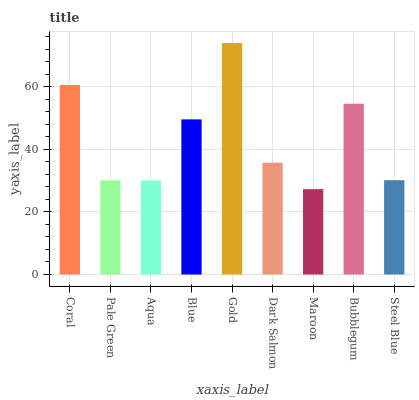Is Maroon the minimum?
Answer yes or no. Yes. Is Gold the maximum?
Answer yes or no. Yes. Is Pale Green the minimum?
Answer yes or no. No. Is Pale Green the maximum?
Answer yes or no. No. Is Coral greater than Pale Green?
Answer yes or no. Yes. Is Pale Green less than Coral?
Answer yes or no. Yes. Is Pale Green greater than Coral?
Answer yes or no. No. Is Coral less than Pale Green?
Answer yes or no. No. Is Dark Salmon the high median?
Answer yes or no. Yes. Is Dark Salmon the low median?
Answer yes or no. Yes. Is Blue the high median?
Answer yes or no. No. Is Pale Green the low median?
Answer yes or no. No. 